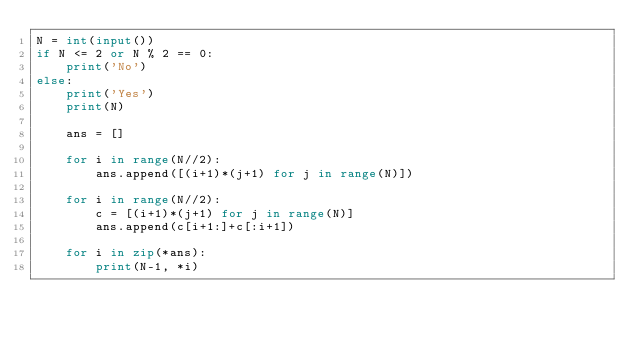Convert code to text. <code><loc_0><loc_0><loc_500><loc_500><_Python_>N = int(input())
if N <= 2 or N % 2 == 0:
    print('No')
else:
    print('Yes')
    print(N)

    ans = []

    for i in range(N//2):
        ans.append([(i+1)*(j+1) for j in range(N)])

    for i in range(N//2):
        c = [(i+1)*(j+1) for j in range(N)]
        ans.append(c[i+1:]+c[:i+1])

    for i in zip(*ans):
        print(N-1, *i)
</code> 